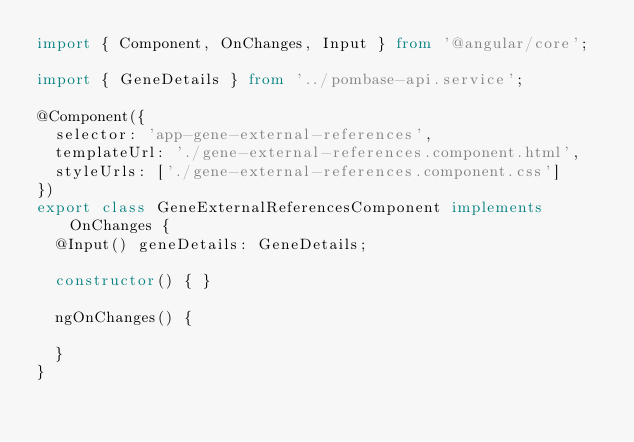Convert code to text. <code><loc_0><loc_0><loc_500><loc_500><_TypeScript_>import { Component, OnChanges, Input } from '@angular/core';

import { GeneDetails } from '../pombase-api.service';

@Component({
  selector: 'app-gene-external-references',
  templateUrl: './gene-external-references.component.html',
  styleUrls: ['./gene-external-references.component.css']
})
export class GeneExternalReferencesComponent implements OnChanges {
  @Input() geneDetails: GeneDetails;

  constructor() { }

  ngOnChanges() {

  }
}
</code> 